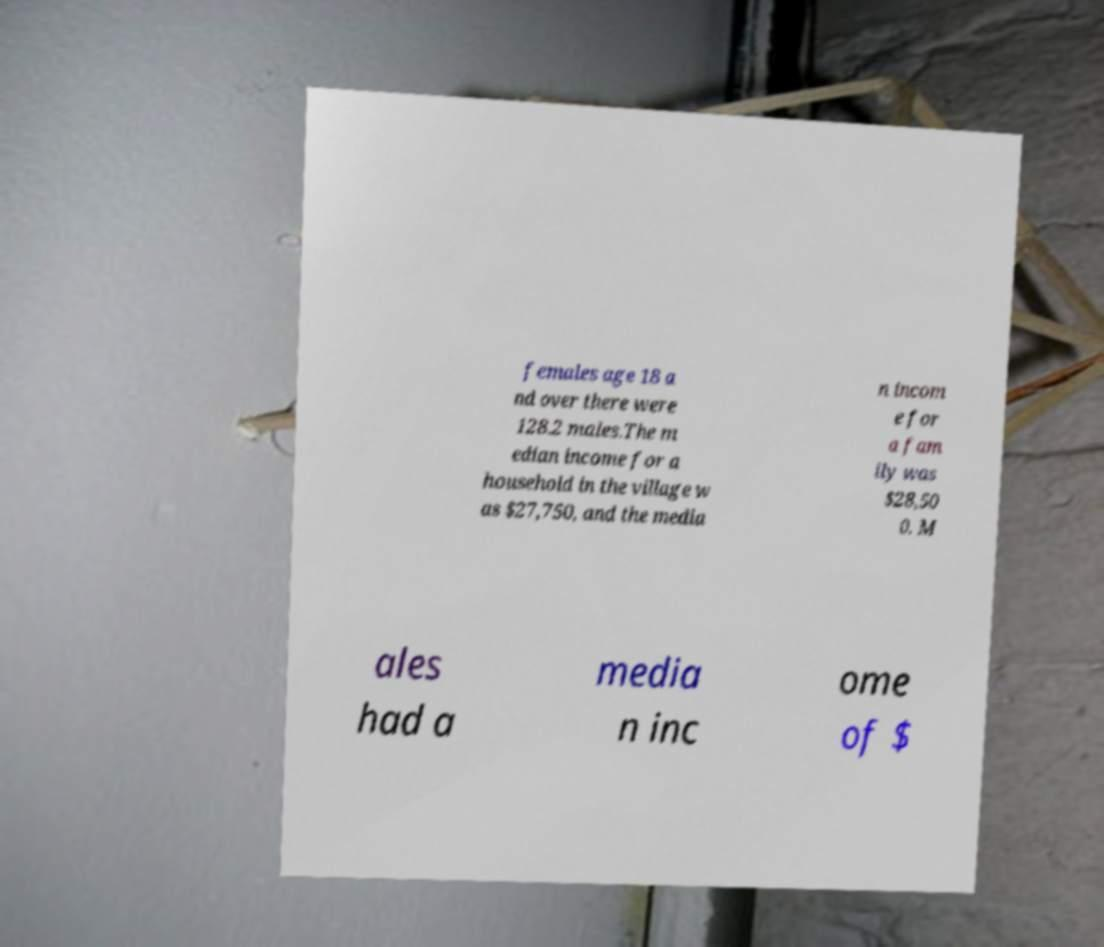For documentation purposes, I need the text within this image transcribed. Could you provide that? females age 18 a nd over there were 128.2 males.The m edian income for a household in the village w as $27,750, and the media n incom e for a fam ily was $28,50 0. M ales had a media n inc ome of $ 